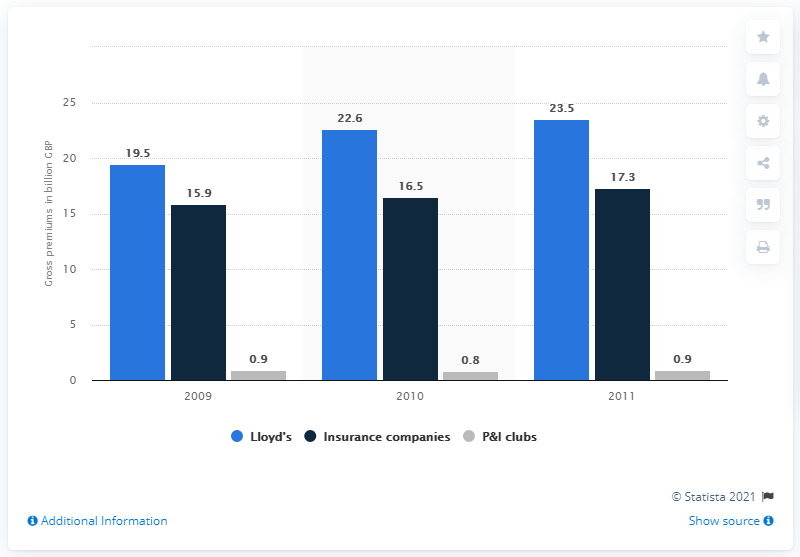Mention a couple of crucial points in this snapshot. Lloyd's gross premium income in 2011 was 23.5. 